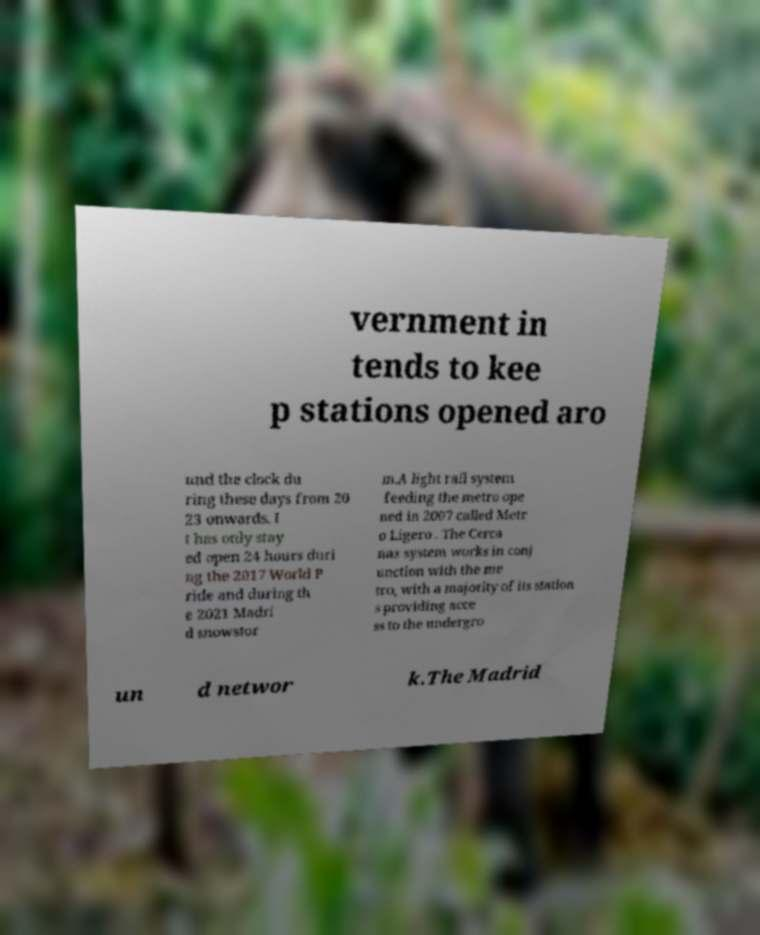Please read and relay the text visible in this image. What does it say? vernment in tends to kee p stations opened aro und the clock du ring these days from 20 23 onwards. I t has only stay ed open 24 hours duri ng the 2017 World P ride and during th e 2021 Madri d snowstor m.A light rail system feeding the metro ope ned in 2007 called Metr o Ligero . The Cerca nas system works in conj unction with the me tro, with a majority of its station s providing acce ss to the undergro un d networ k.The Madrid 